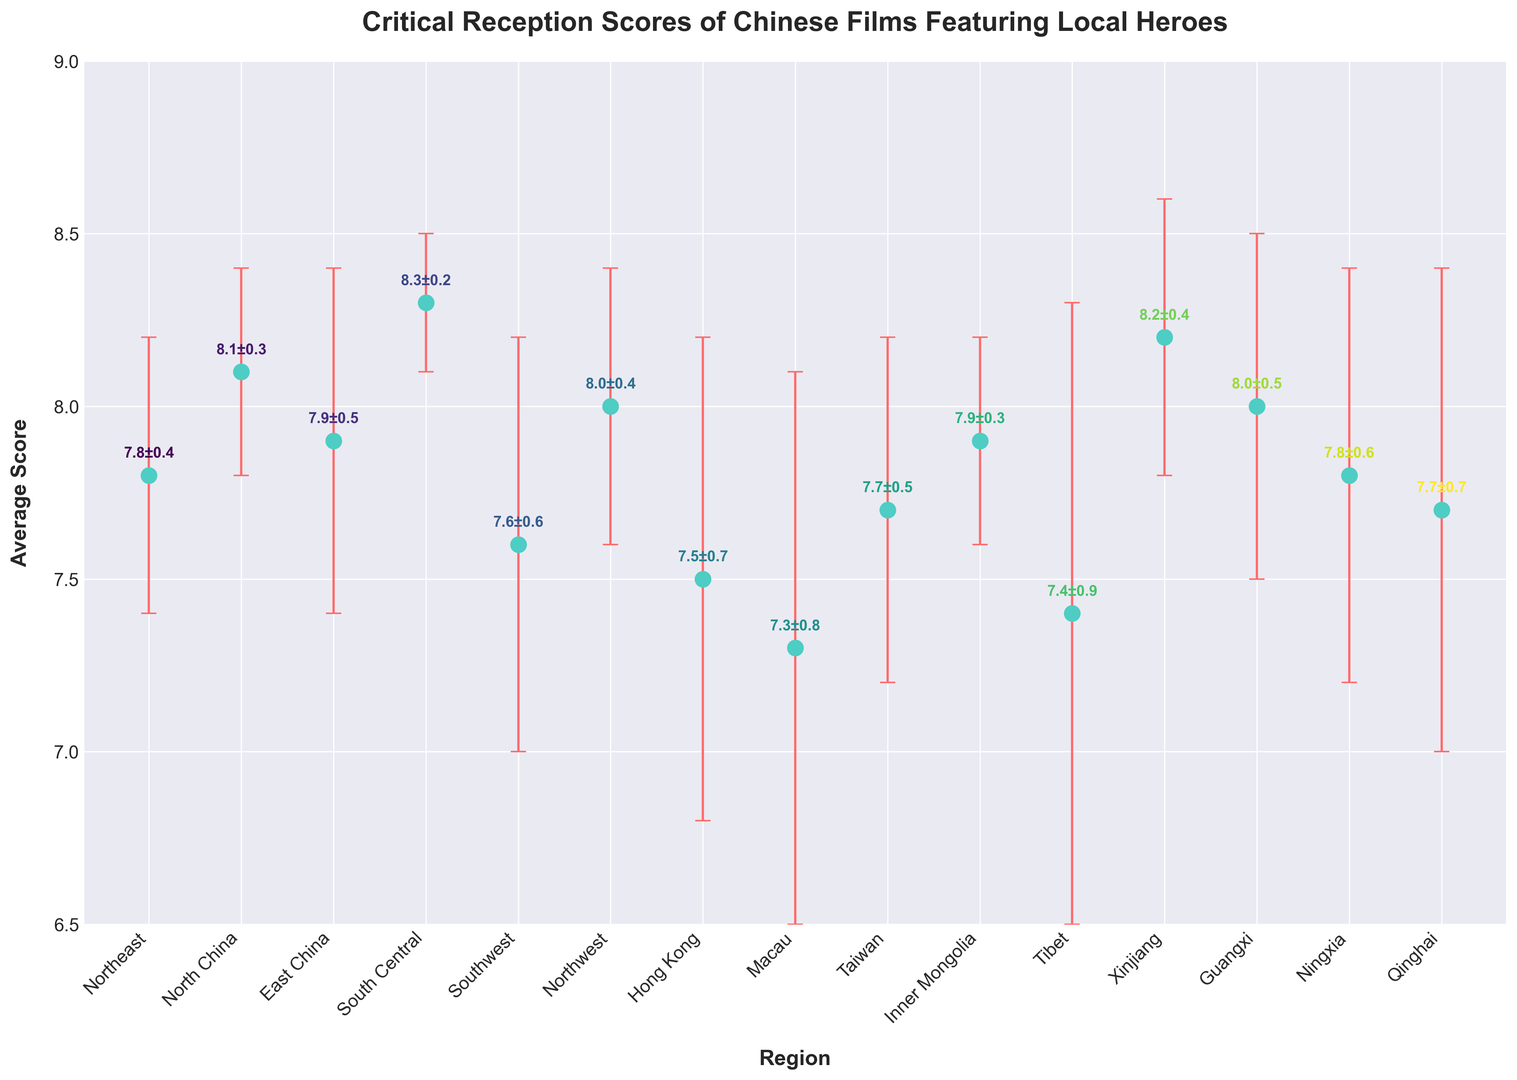Which region has the highest critical reception score for Chinese films? To find this, look for the region with the highest y-value among the points. The highest score is 8.3 in South Central.
Answer: South Central Which region has the lowest critical reception score for Chinese films? Check the chart for the point with the lowest y-value. The lowest score is 7.3 in Macau.
Answer: Macau What is the difference in average scores between the region with the highest and lowest scores? The highest score is 8.3 (South Central) and the lowest is 7.3 (Macau). Subtract the lowest score from the highest score: 8.3 - 7.3.
Answer: 1.0 Which regions have average scores greater than 8.0? Identify all regions where the points lie above the 8.0 mark on the y-axis. These regions are North China (8.1), South Central (8.3), Xinjiang (8.2).
Answer: North China, South Central, Xinjiang What is the average critical reception score across all regions? Calculate the mean of all average scores: (7.8 + 8.1 + 7.9 + 8.3 + 7.6 + 8.0 + 7.5 + 7.3 + 7.7 + 7.9 + 7.4 + 8.2 + 8.0 + 7.8 + 7.7)/15. Total is 116.2, so the average is 116.2/15.
Answer: 7.75 Which region has the largest error margin? Identify the highest error margin by visually checking the extent of the error bars. The largest error margin is 0.9 in Tibet.
Answer: Tibet How does the average score of Hong Kong compare to that of Taiwan? Compare the points directly. Hong Kong’s score is 7.5, and Taiwan’s score is 7.7. Hong Kong’s score is lower.
Answer: Hong Kong is lower What is the sum of scores for regions with error margins less than 0.5? Identify regions with error margins less than 0.5: North China (8.1), South Central (8.3), Inner Mongolia (7.9). Add these scores: 8.1 + 8.3 + 7.9.
Answer: 24.3 What is the median critical reception score of the regions? Order the scores: 7.3, 7.4, 7.5, 7.6, 7.7, 7.7, 7.8, 7.8, 7.9, 7.9, 8.0, 8.0, 8.1, 8.2, 8.3. The middle value (8th value) is the median: 7.8.
Answer: 7.8 Which regions have average scores within the error margin of the highest-scoring region (South Central)? South Central's score is 8.3 ± 0.2, so acceptable range is 8.1 to 8.5. The regions within this range are North China (8.1), North Central (8.0), Xinjiang (8.2).
Answer: North China, Xinjiang 